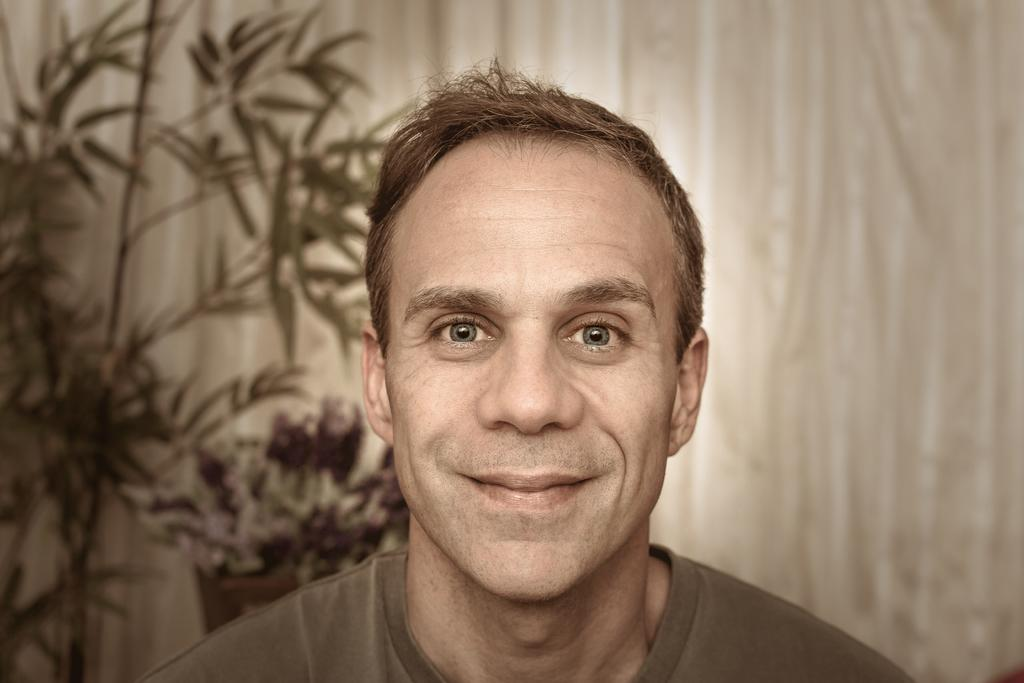What is the main subject of the image? The main subject of the image is a man. What is the man wearing in the image? The man is wearing a t-shirt in the image. What is the man's facial expression in the image? The man is smiling in the image. What type of material is visible in the image? Cloth is visible in the image. What type of plant can be seen in the image? There is a plant in the image, and it has flowers. What is the plant in the image contained in? The plant is in a pot in the image. What type of truck can be seen in the image? There is no truck present in the image. What type of glove is the man wearing in the image? The man is not wearing a glove in the image; he is wearing a t-shirt. 